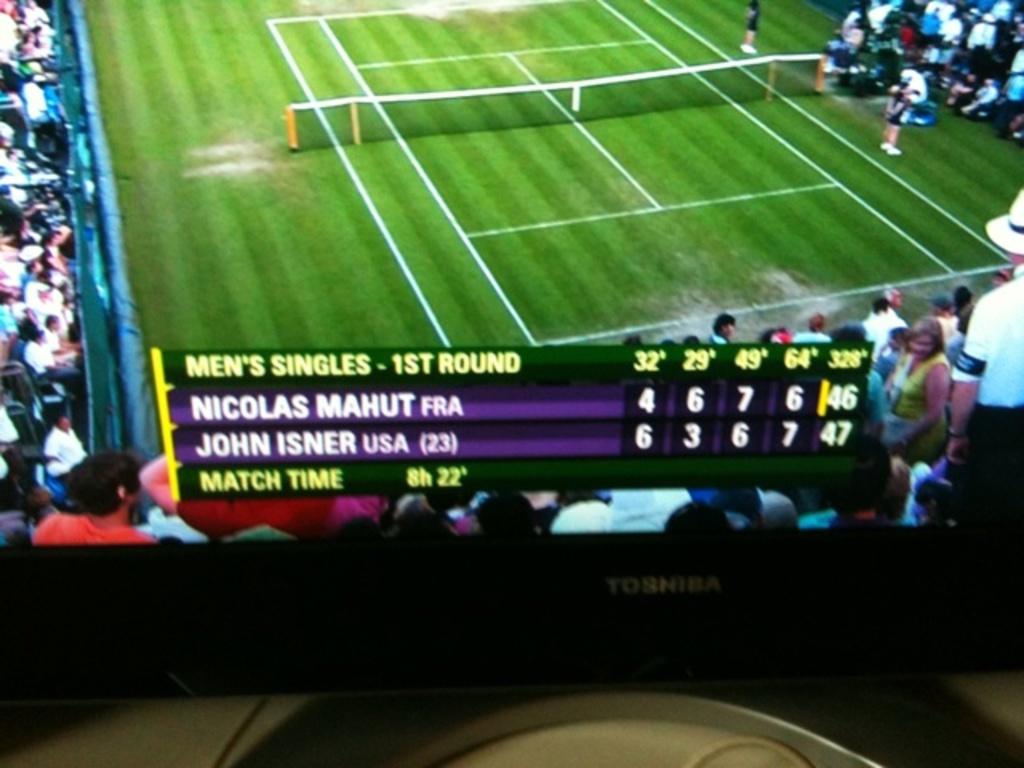Which player is from the usa?
Provide a succinct answer. John isner. Who is the player from france?
Offer a very short reply. Nicolas mahut. 